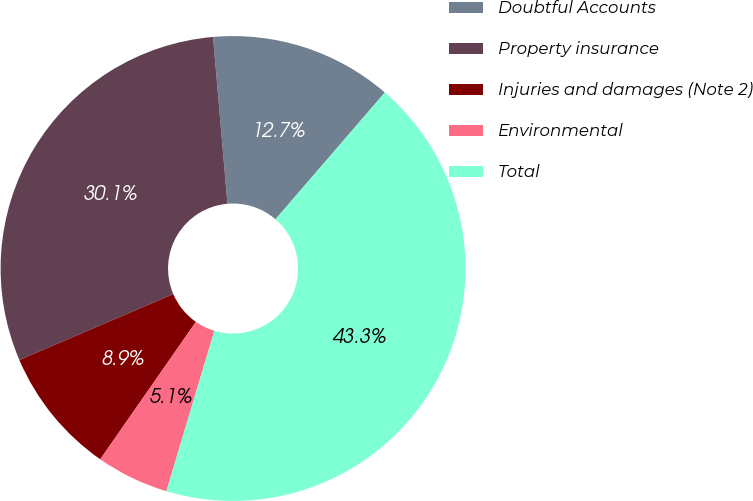Convert chart. <chart><loc_0><loc_0><loc_500><loc_500><pie_chart><fcel>Doubtful Accounts<fcel>Property insurance<fcel>Injuries and damages (Note 2)<fcel>Environmental<fcel>Total<nl><fcel>12.7%<fcel>30.07%<fcel>8.88%<fcel>5.05%<fcel>43.3%<nl></chart> 